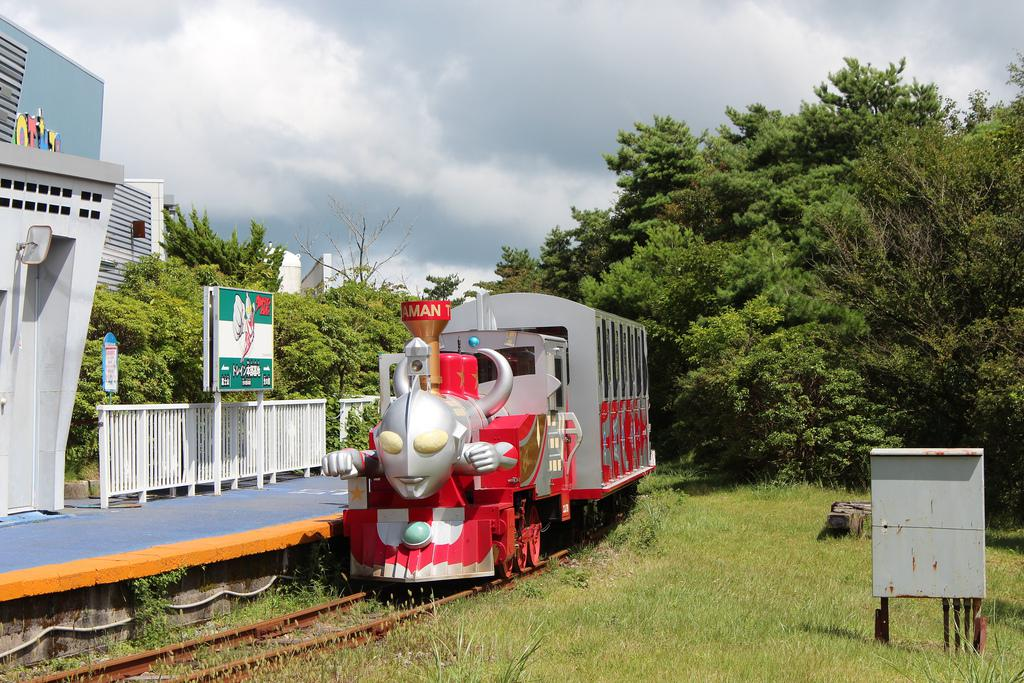Question: what color is the control box to the right of the train?
Choices:
A. White.
B. Black.
C. Gray.
D. Green.
Answer with the letter. Answer: C Question: what face has curling horns and pupil-less white, oval eyes?
Choices:
A. A donkey.
B. The ram.
C. Devil face.
D. An elephant.
Answer with the letter. Answer: C Question: how does the sky look?
Choices:
A. Cloudy.
B. Sunny.
C. Clear.
D. Overcast.
Answer with the letter. Answer: A Question: what color are the eyes of the object in front of the train?
Choices:
A. Green.
B. Red.
C. Yellow.
D. Blue.
Answer with the letter. Answer: C Question: how many people are shown in this picture?
Choices:
A. Ten.
B. Zero.
C. Six.
D. Three.
Answer with the letter. Answer: B Question: what color is the face of the object on the front of the train?
Choices:
A. White.
B. Black.
C. Grey.
D. Brown.
Answer with the letter. Answer: C Question: what shape is the grey sign stands about level with the front of the train engine in the grass?
Choices:
A. Trapezoid.
B. Triangle.
C. Square.
D. Rectangle.
Answer with the letter. Answer: D Question: what is near the end of the white fence on the platform?
Choices:
A. The man.
B. The car.
C. The road.
D. A building.
Answer with the letter. Answer: D Question: what color is the edge of the platform?
Choices:
A. Yellow.
B. Red.
C. Silver.
D. Black.
Answer with the letter. Answer: A Question: what is the main focus of this picture?
Choices:
A. A train.
B. A Bus.
C. A Car.
D. A Truck.
Answer with the letter. Answer: A Question: when time of day was this picture taken?
Choices:
A. Daytime.
B. Morning.
C. Afternoon.
D. Nighttime.
Answer with the letter. Answer: A Question: what stretches backward from the left lower corner of the image?
Choices:
A. The platform.
B. The floor.
C. The umbrella.
D. The road.
Answer with the letter. Answer: A Question: what is above building on left?
Choices:
A. Billboard.
B. Sign.
C. Skylight.
D. Blimp.
Answer with the letter. Answer: B Question: what should happen to the grass?
Choices:
A. It needs to be watered.
B. It needs to be sodded.
C. It needs to be fertilized.
D. It needs to be cut.
Answer with the letter. Answer: D 